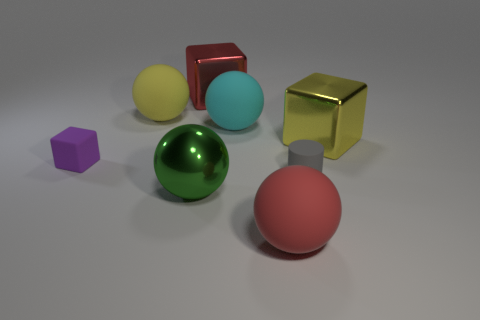Add 1 big things. How many objects exist? 9 Subtract all blocks. How many objects are left? 5 Subtract 0 red cylinders. How many objects are left? 8 Subtract all small green objects. Subtract all large red rubber balls. How many objects are left? 7 Add 7 tiny rubber cylinders. How many tiny rubber cylinders are left? 8 Add 5 big green shiny balls. How many big green shiny balls exist? 6 